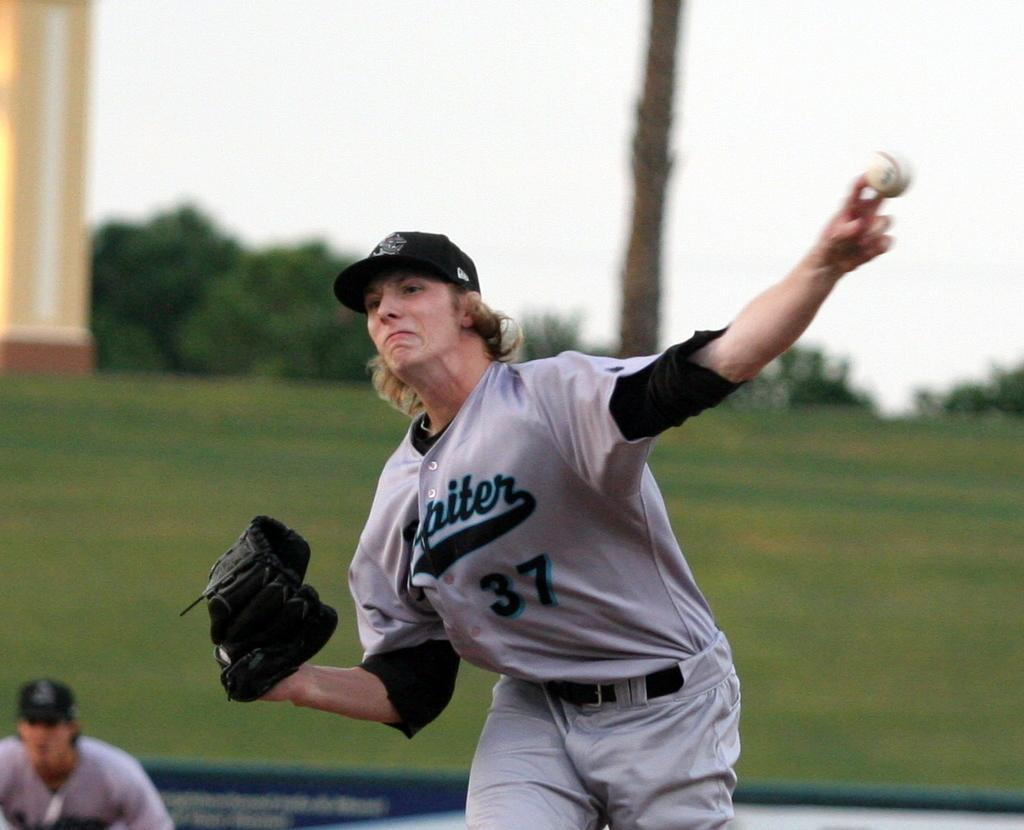<image>
Render a clear and concise summary of the photo. A female baseball player is pitching a ball and her uniform says Jupiter 37. 